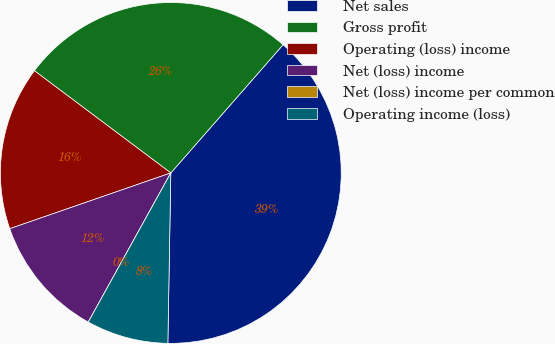Convert chart to OTSL. <chart><loc_0><loc_0><loc_500><loc_500><pie_chart><fcel>Net sales<fcel>Gross profit<fcel>Operating (loss) income<fcel>Net (loss) income<fcel>Net (loss) income per common<fcel>Operating income (loss)<nl><fcel>38.83%<fcel>26.21%<fcel>15.54%<fcel>11.65%<fcel>0.0%<fcel>7.77%<nl></chart> 